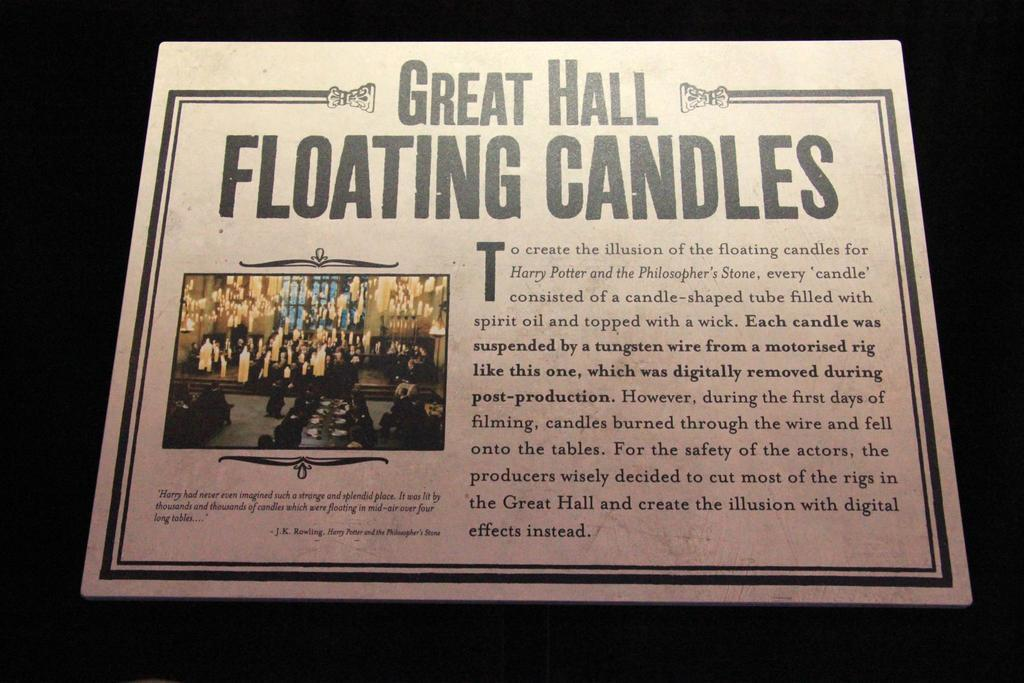<image>
Render a clear and concise summary of the photo. A sign is about the floating candles in Hogwart's great hall. 